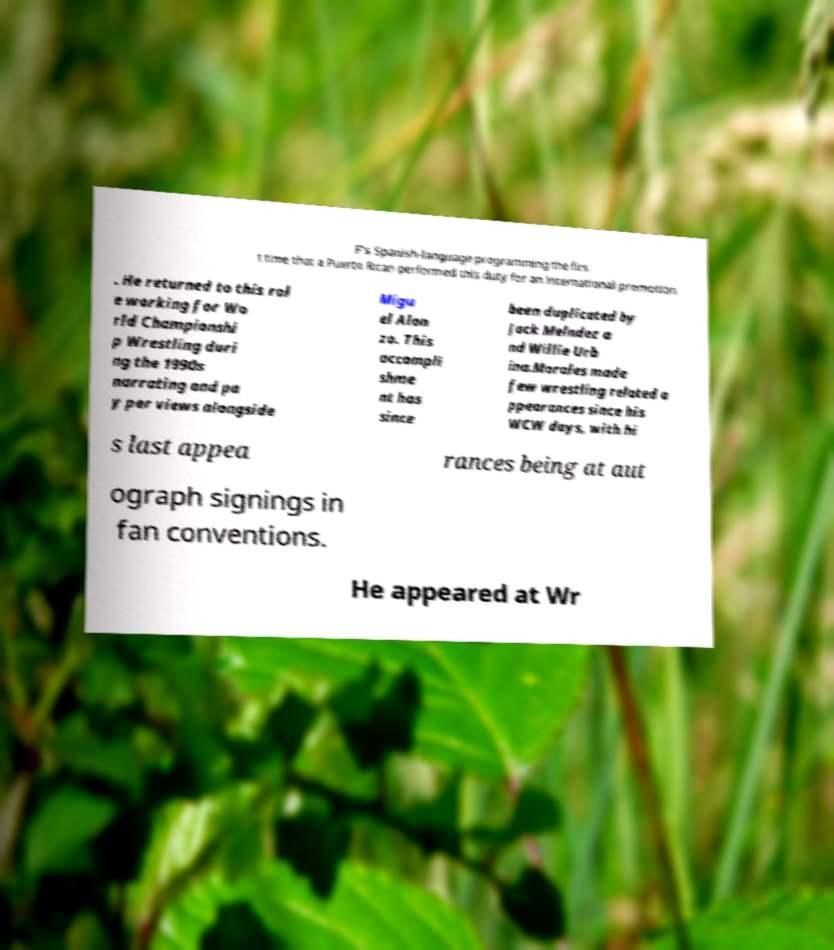Could you extract and type out the text from this image? F's Spanish-language programming the firs t time that a Puerto Rican performed this duty for an international promotion . He returned to this rol e working for Wo rld Championshi p Wrestling duri ng the 1990s narrating and pa y per views alongside Migu el Alon zo. This accompli shme nt has since been duplicated by Jack Melndez a nd Willie Urb ina.Morales made few wrestling related a ppearances since his WCW days, with hi s last appea rances being at aut ograph signings in fan conventions. He appeared at Wr 